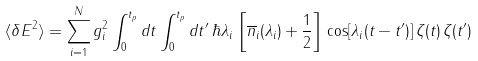Convert formula to latex. <formula><loc_0><loc_0><loc_500><loc_500>\langle \delta E ^ { 2 } \rangle = \sum _ { i = 1 } ^ { N } g _ { i } ^ { 2 } \int _ { 0 } ^ { t _ { p } } d t \int _ { 0 } ^ { t _ { p } } d t ^ { \prime } \, \hbar { \lambda } _ { i } \, \left [ \overline { n } _ { i } ( \lambda _ { i } ) + \frac { 1 } { 2 } \right ] \, \cos [ \lambda _ { i } ( t - t ^ { \prime } ) ] \, \zeta ( t ) \, \zeta ( t ^ { \prime } )</formula> 